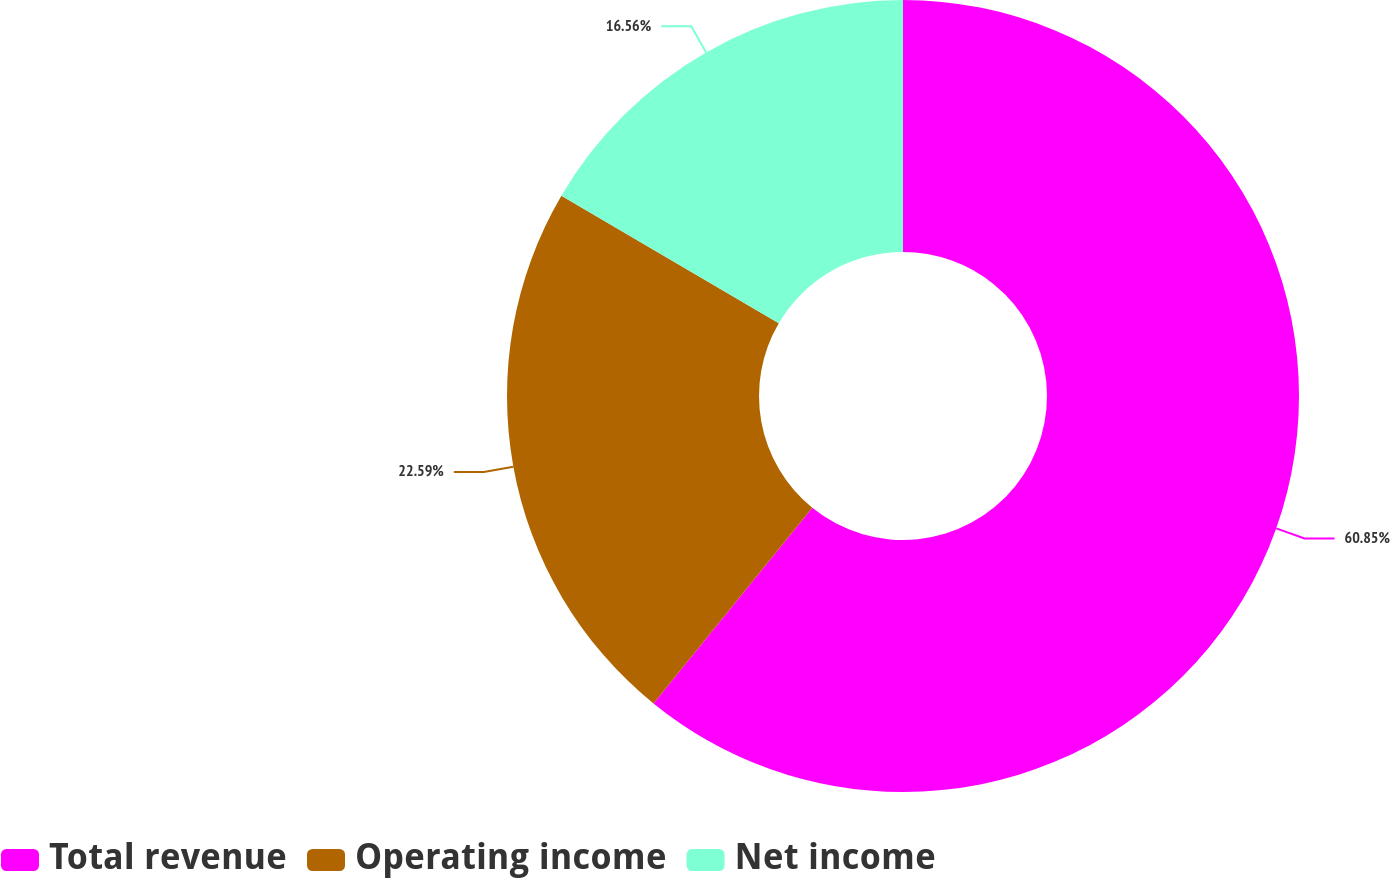<chart> <loc_0><loc_0><loc_500><loc_500><pie_chart><fcel>Total revenue<fcel>Operating income<fcel>Net income<nl><fcel>60.85%<fcel>22.59%<fcel>16.56%<nl></chart> 